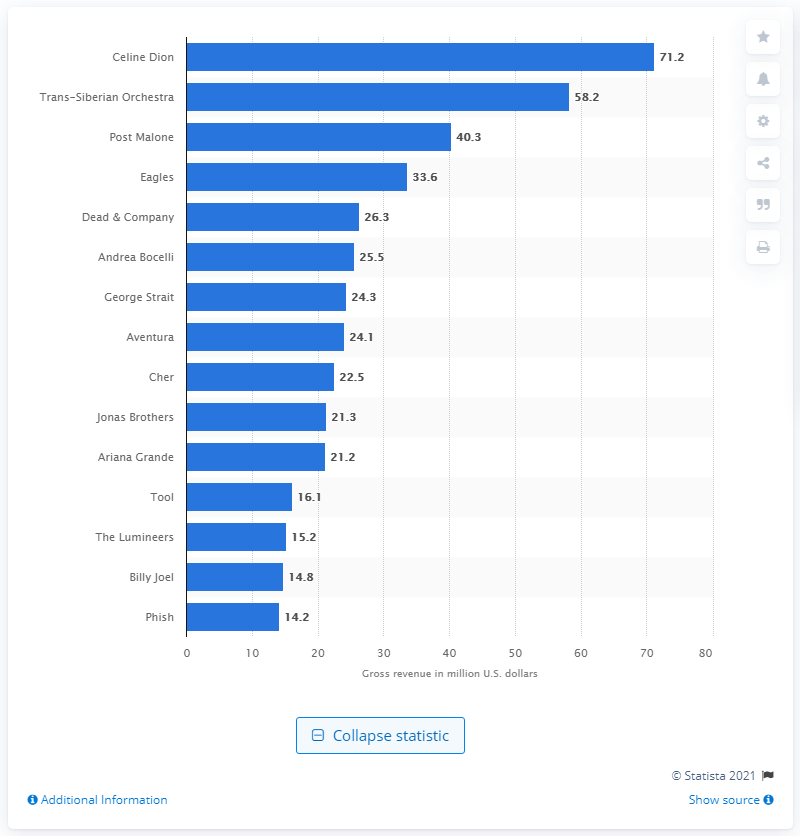Indicate a few pertinent items in this graphic. Celine Dion generated approximately 71.2 million dollars in the United States in 2020. 